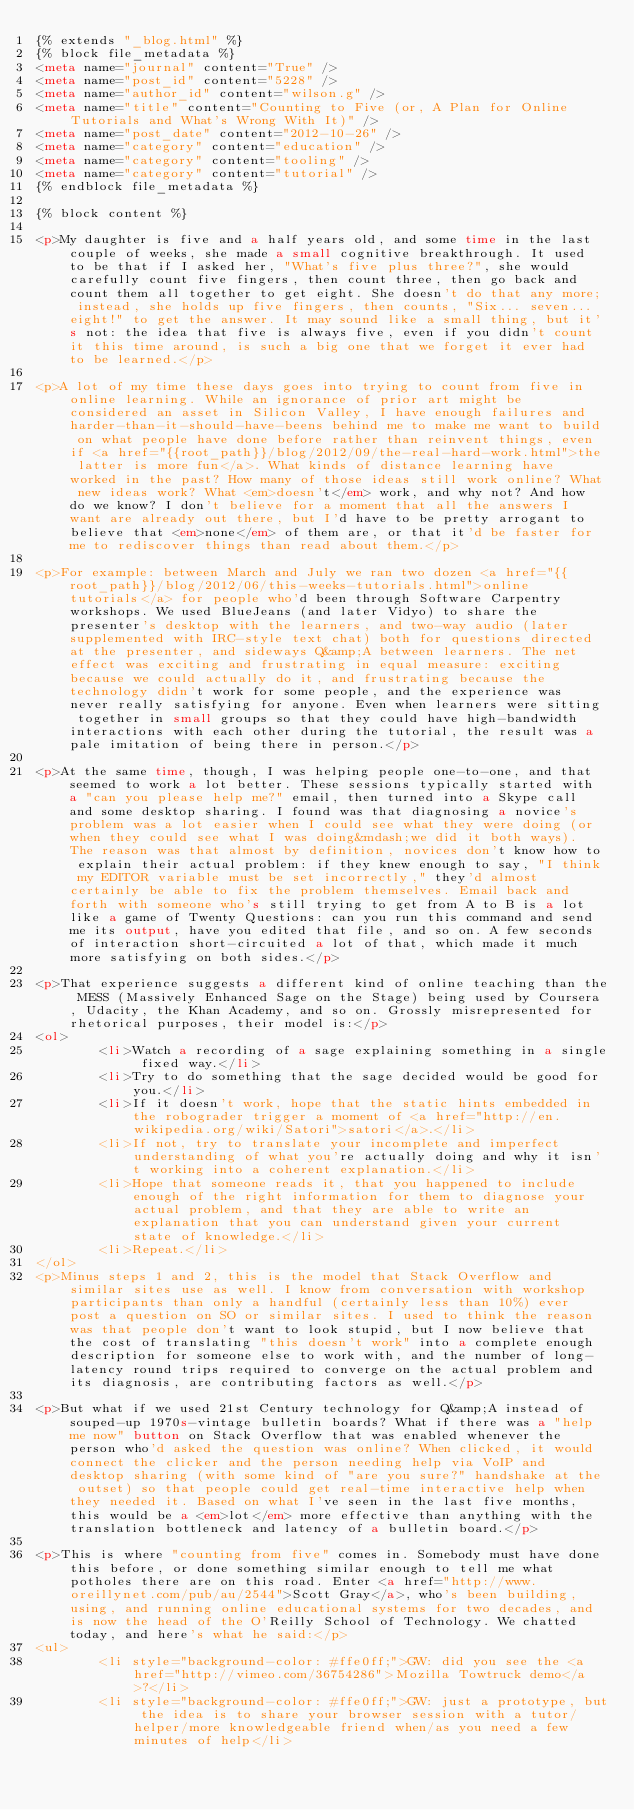Convert code to text. <code><loc_0><loc_0><loc_500><loc_500><_HTML_>{% extends "_blog.html" %}
{% block file_metadata %}
<meta name="journal" content="True" />
<meta name="post_id" content="5228" />
<meta name="author_id" content="wilson.g" />
<meta name="title" content="Counting to Five (or, A Plan for Online Tutorials and What's Wrong With It)" />
<meta name="post_date" content="2012-10-26" />
<meta name="category" content="education" />
<meta name="category" content="tooling" />
<meta name="category" content="tutorial" />
{% endblock file_metadata %}

{% block content %}

<p>My daughter is five and a half years old, and some time in the last couple of weeks, she made a small cognitive breakthrough. It used to be that if I asked her, "What's five plus three?", she would carefully count five fingers, then count three, then go back and count them all together to get eight. She doesn't do that any more; instead, she holds up five fingers, then counts, "Six... seven... eight!" to get the answer. It may sound like a small thing, but it's not: the idea that five is always five, even if you didn't count it this time around, is such a big one that we forget it ever had to be learned.</p>

<p>A lot of my time these days goes into trying to count from five in online learning. While an ignorance of prior art might be considered an asset in Silicon Valley, I have enough failures and harder-than-it-should-have-beens behind me to make me want to build on what people have done before rather than reinvent things, even if <a href="{{root_path}}/blog/2012/09/the-real-hard-work.html">the latter is more fun</a>. What kinds of distance learning have worked in the past? How many of those ideas still work online? What new ideas work? What <em>doesn't</em> work, and why not? And how do we know? I don't believe for a moment that all the answers I want are already out there, but I'd have to be pretty arrogant to believe that <em>none</em> of them are, or that it'd be faster for me to rediscover things than read about them.</p>

<p>For example: between March and July we ran two dozen <a href="{{root_path}}/blog/2012/06/this-weeks-tutorials.html">online tutorials</a> for people who'd been through Software Carpentry workshops. We used BlueJeans (and later Vidyo) to share the presenter's desktop with the learners, and two-way audio (later supplemented with IRC-style text chat) both for questions directed at the presenter, and sideways Q&amp;A between learners. The net effect was exciting and frustrating in equal measure: exciting because we could actually do it, and frustrating because the technology didn't work for some people, and the experience was never really satisfying for anyone. Even when learners were sitting together in small groups so that they could have high-bandwidth interactions with each other during the tutorial, the result was a pale imitation of being there in person.</p>

<p>At the same time, though, I was helping people one-to-one, and that seemed to work a lot better. These sessions typically started with a "can you please help me?" email, then turned into a Skype call and some desktop sharing. I found was that diagnosing a novice's problem was a lot easier when I could see what they were doing (or when they could see what I was doing&mdash;we did it both ways). The reason was that almost by definition, novices don't know how to explain their actual problem: if they knew enough to say, "I think my EDITOR variable must be set incorrectly," they'd almost certainly be able to fix the problem themselves. Email back and forth with someone who's still trying to get from A to B is a lot like a game of Twenty Questions: can you run this command and send me its output, have you edited that file, and so on. A few seconds of interaction short-circuited a lot of that, which made it much more satisfying on both sides.</p>

<p>That experience suggests a different kind of online teaching than the MESS (Massively Enhanced Sage on the Stage) being used by Coursera, Udacity, the Khan Academy, and so on. Grossly misrepresented for rhetorical purposes, their model is:</p>
<ol>
        <li>Watch a recording of a sage explaining something in a single fixed way.</li>
        <li>Try to do something that the sage decided would be good for you.</li>
        <li>If it doesn't work, hope that the static hints embedded in the robograder trigger a moment of <a href="http://en.wikipedia.org/wiki/Satori">satori</a>.</li>
        <li>If not, try to translate your incomplete and imperfect understanding of what you're actually doing and why it isn't working into a coherent explanation.</li>
        <li>Hope that someone reads it, that you happened to include enough of the right information for them to diagnose your actual problem, and that they are able to write an explanation that you can understand given your current state of knowledge.</li>
        <li>Repeat.</li>
</ol>
<p>Minus steps 1 and 2, this is the model that Stack Overflow and similar sites use as well. I know from conversation with workshop participants than only a handful (certainly less than 10%) ever post a question on SO or similar sites. I used to think the reason was that people don't want to look stupid, but I now believe that the cost of translating "this doesn't work" into a complete enough description for someone else to work with, and the number of long-latency round trips required to converge on the actual problem and its diagnosis, are contributing factors as well.</p>

<p>But what if we used 21st Century technology for Q&amp;A instead of souped-up 1970s-vintage bulletin boards? What if there was a "help me now" button on Stack Overflow that was enabled whenever the person who'd asked the question was online? When clicked, it would connect the clicker and the person needing help via VoIP and desktop sharing (with some kind of "are you sure?" handshake at the outset) so that people could get real-time interactive help when they needed it. Based on what I've seen in the last five months, this would be a <em>lot</em> more effective than anything with the translation bottleneck and latency of a bulletin board.</p>

<p>This is where "counting from five" comes in. Somebody must have done this before, or done something similar enough to tell me what potholes there are on this road. Enter <a href="http://www.oreillynet.com/pub/au/2544">Scott Gray</a>, who's been building, using, and running online educational systems for two decades, and is now the head of the O'Reilly School of Technology. We chatted today, and here's what he said:</p>
<ul>
        <li style="background-color: #ffe0ff;">GW: did you see the <a href="http://vimeo.com/36754286">Mozilla Towtruck demo</a>?</li>
        <li style="background-color: #ffe0ff;">GW: just a prototype, but the idea is to share your browser session with a tutor/helper/more knowledgeable friend when/as you need a few minutes of help</li></code> 